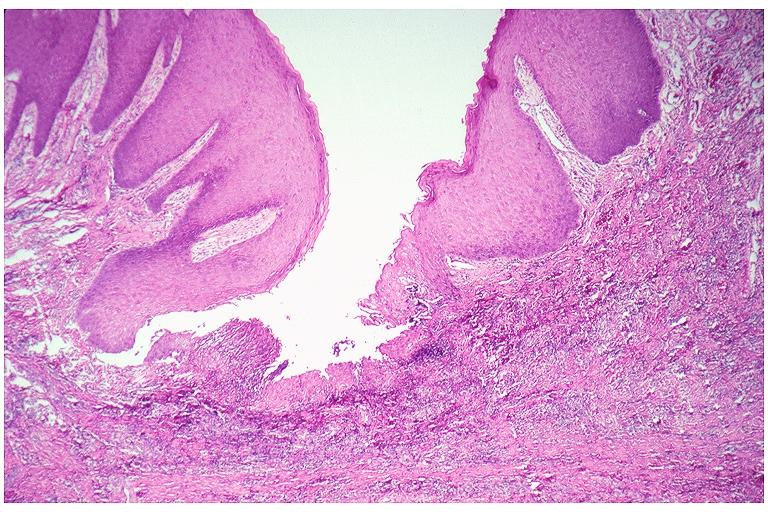does penis show epulis fissuratum?
Answer the question using a single word or phrase. No 